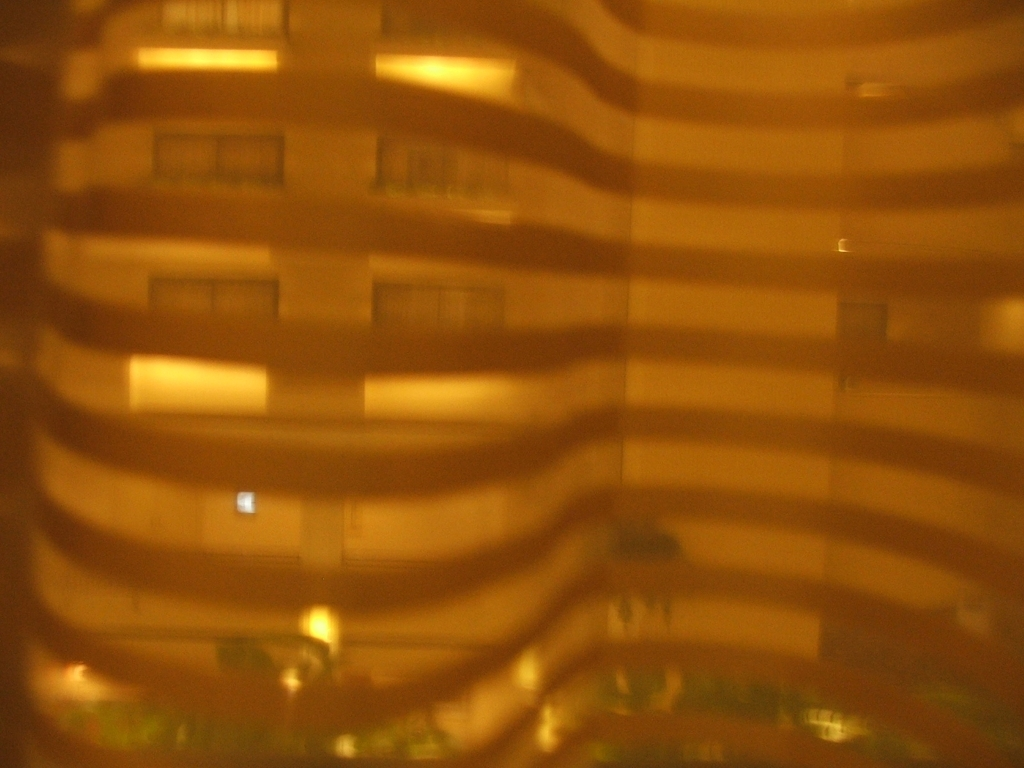What time of day does this photo seem to be taken? The image seems to be captured at night, evident from the artificial lighting seen through the windows and the overall darkness surrounding the structure. 